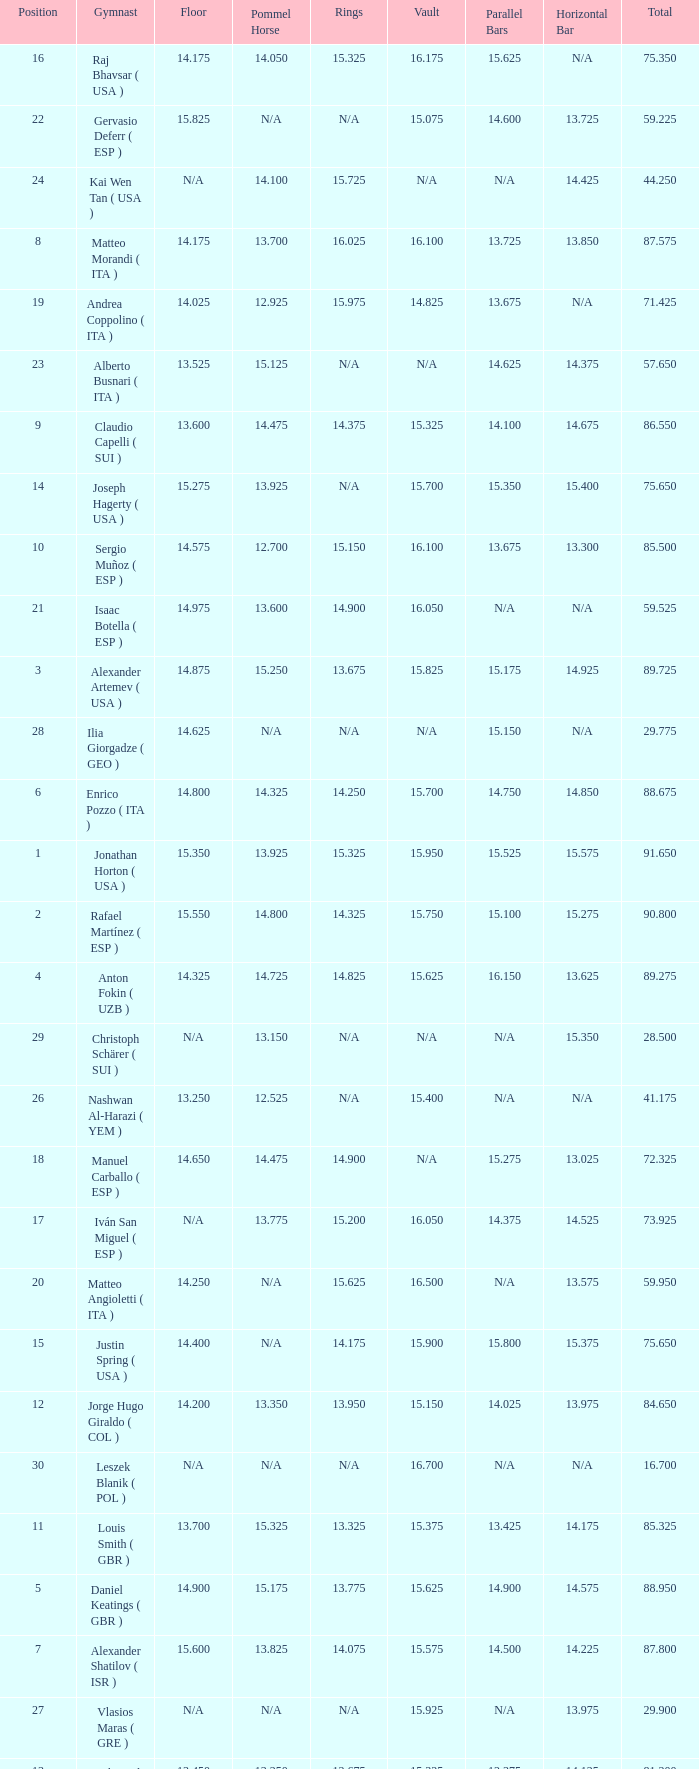If the parallel bars is 16.150, who is the gymnast? Anton Fokin ( UZB ). 